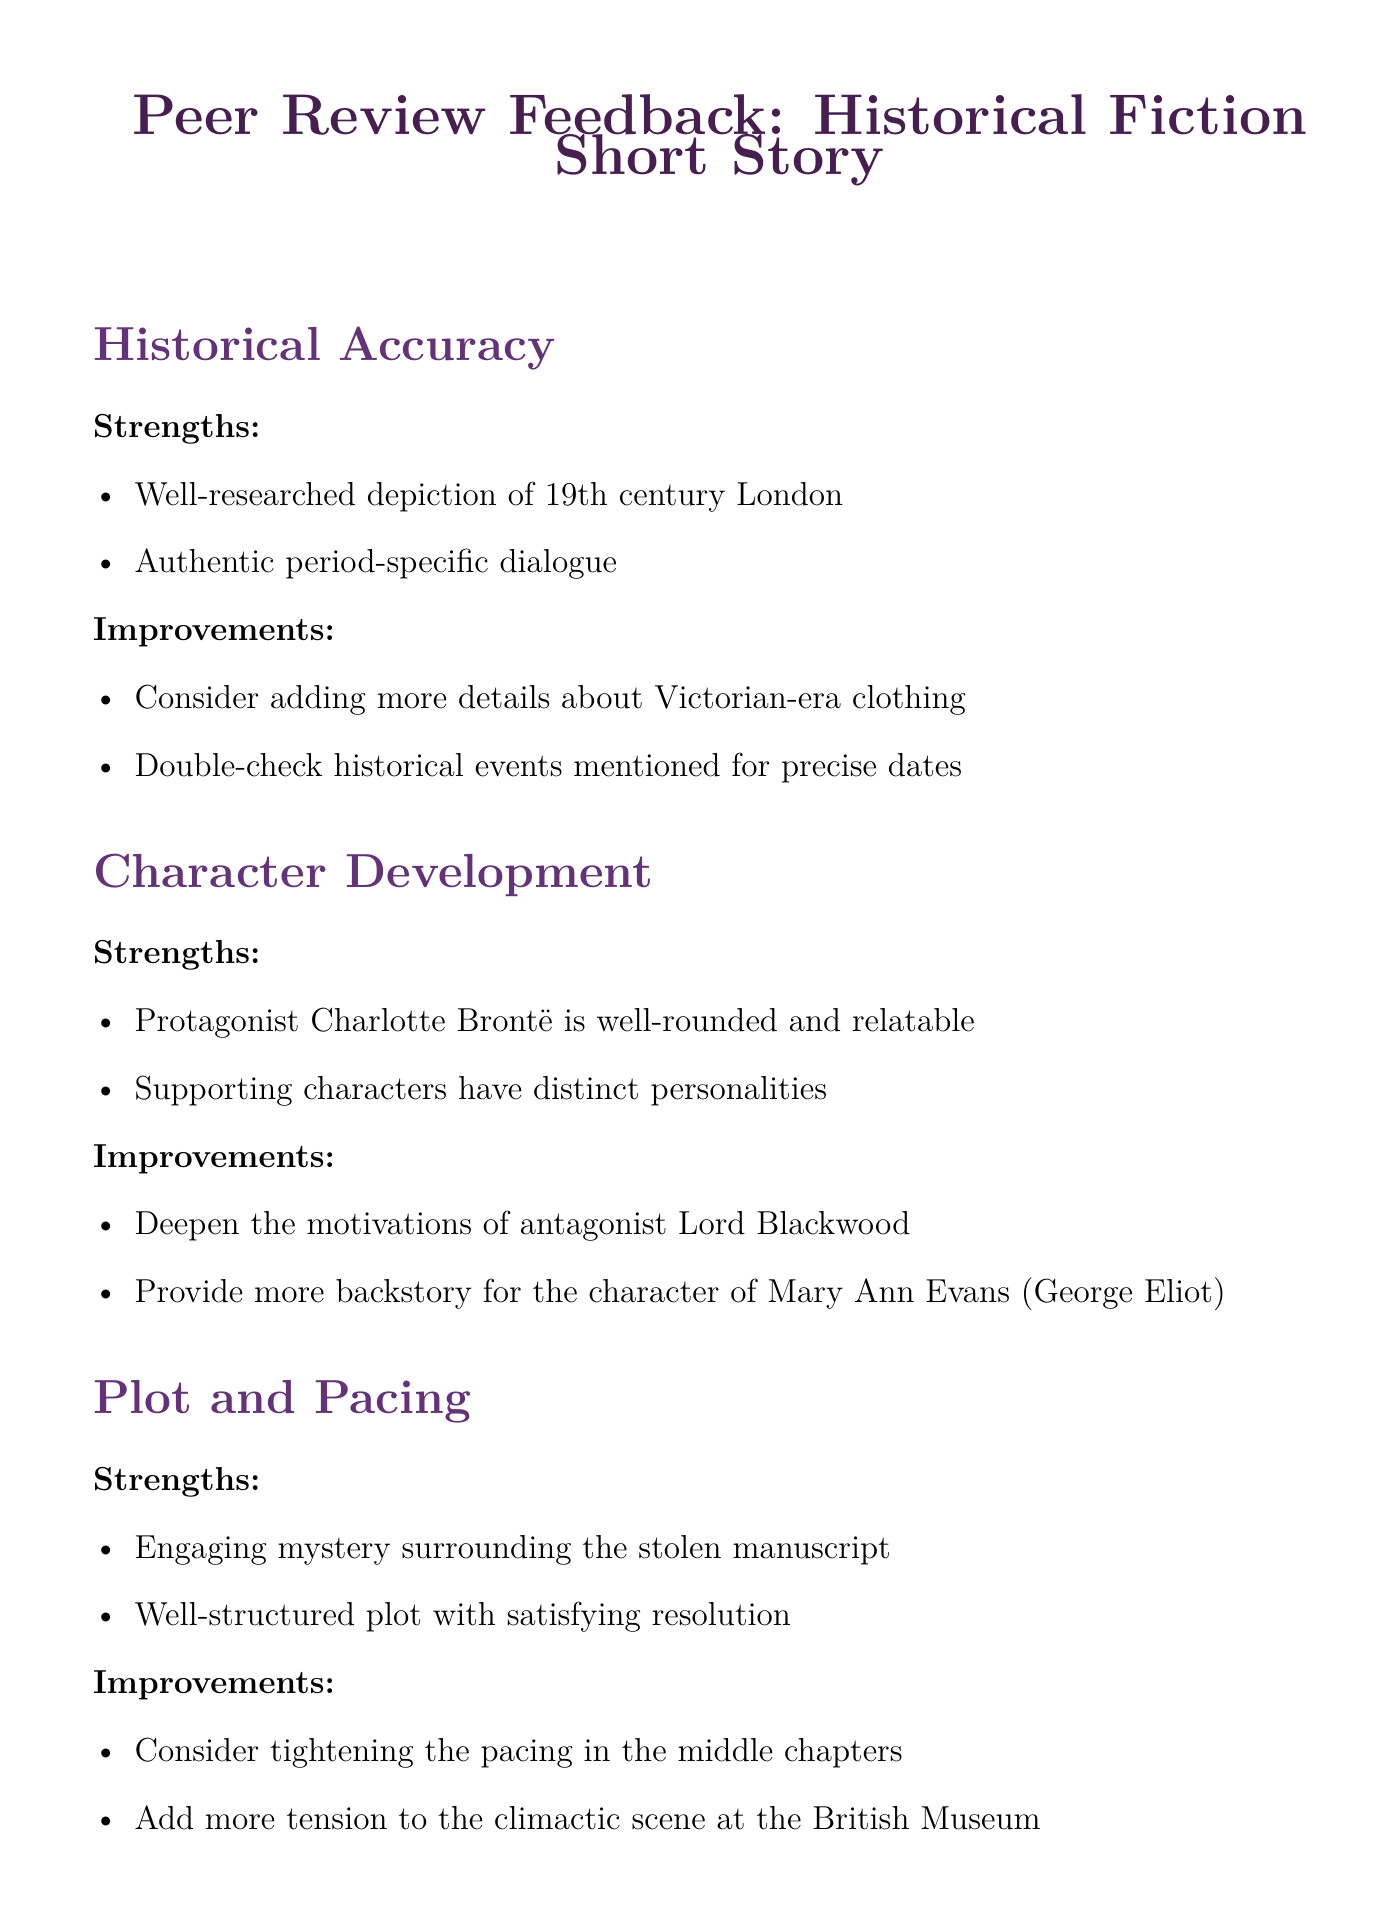What are two strengths of historical accuracy? The document lists the strengths under the section "Historical Accuracy," which includes a well-researched depiction of 19th century London and authentic period-specific dialogue.
Answer: Well-researched depiction of 19th century London, authentic period-specific dialogue What is one area for improvement in character development? The document specifies areas for improvement under the section "Character Development," indicating that the motivations of antagonist Lord Blackwood should be deepened.
Answer: Deepen the motivations of antagonist Lord Blackwood What is the overall impression of the short story? The document provides an overall impression summarizing the quality and potential of the story, stating it is a promising piece with strong character work and an engaging plot.
Answer: A promising historical fiction short story with strong character work and an engaging plot How many strengths are listed under writing style? The document includes two strengths listed in the "Writing Style" section.
Answer: Two What thematic element involves women's roles? The document highlights the exploration of women's roles in 19th century literature as a thematic element.
Answer: Exploration of women's roles in 19th century literature What is a suggested improvement related to pacing? In the "Plot and Pacing" section, the document suggests tightening the pacing in the middle chapters as an improvement.
Answer: Tightening the pacing in the middle chapters Which character's backstory should be expanded? The document indicates that more backstory should be provided for the character of Mary Ann Evans (George Eliot).
Answer: Mary Ann Evans (George Eliot) What type of feedback does this document contain? The document primarily contains peer review feedback compilation structured into strengths and areas for improvement across various aspects.
Answer: Peer review feedback compilation 